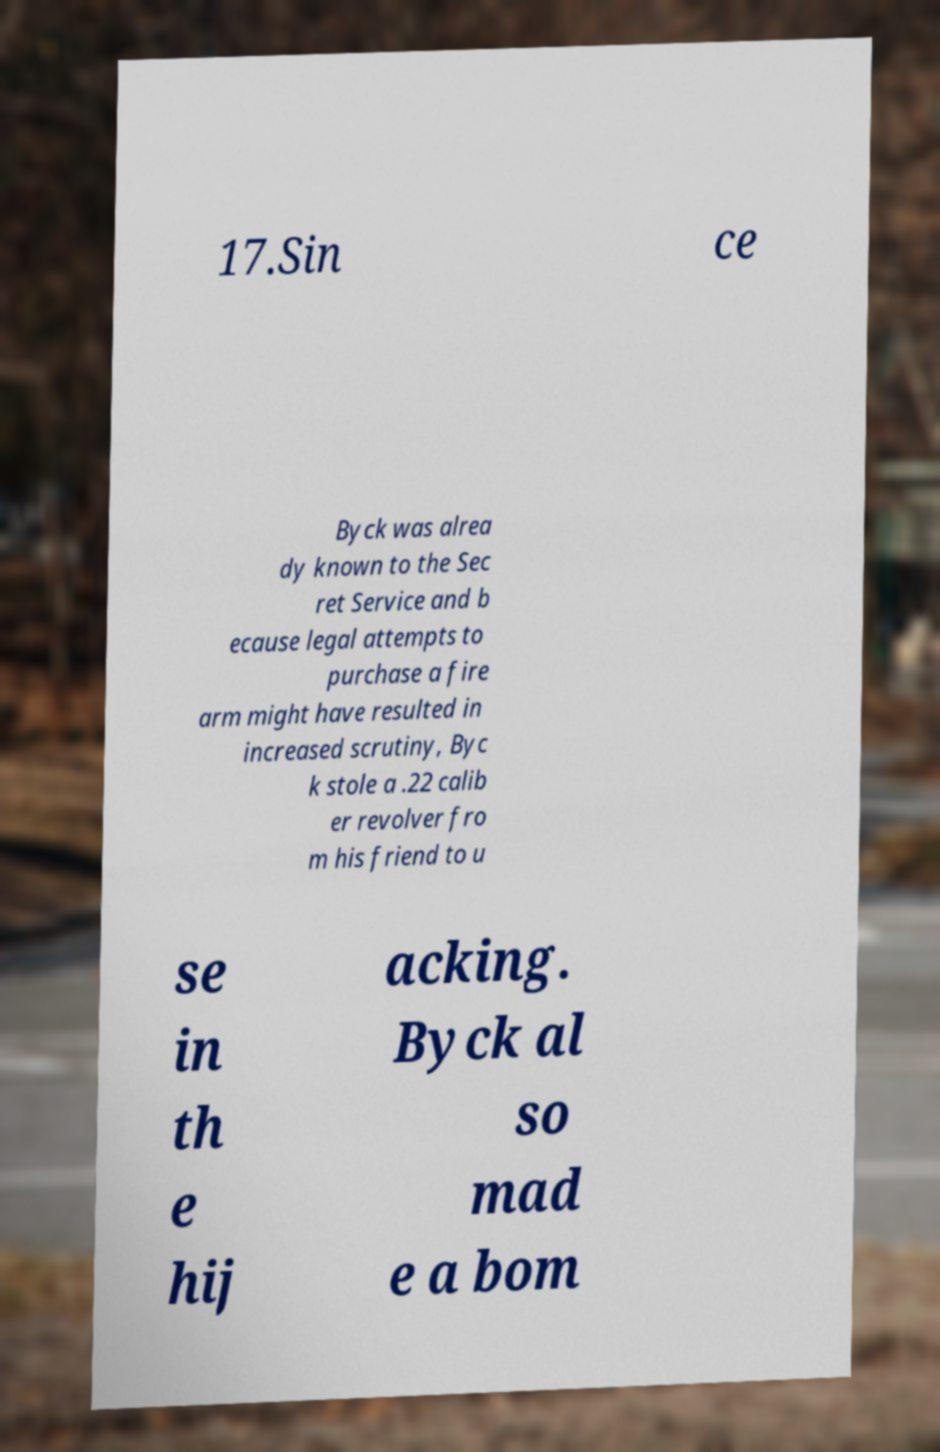For documentation purposes, I need the text within this image transcribed. Could you provide that? 17.Sin ce Byck was alrea dy known to the Sec ret Service and b ecause legal attempts to purchase a fire arm might have resulted in increased scrutiny, Byc k stole a .22 calib er revolver fro m his friend to u se in th e hij acking. Byck al so mad e a bom 